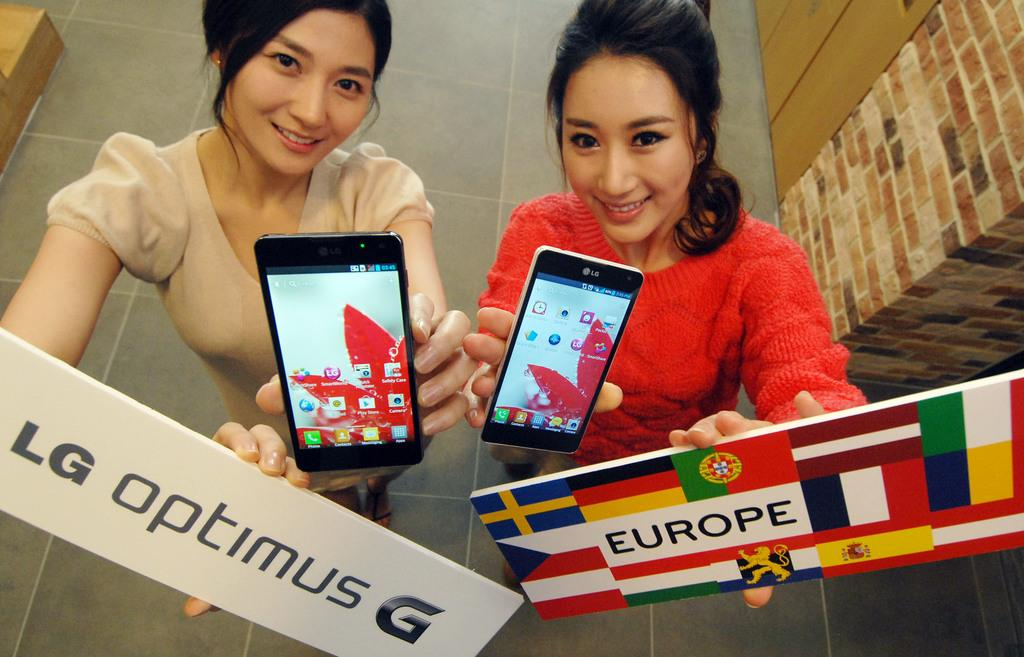<image>
Render a clear and concise summary of the photo. Two women holding LG optimus G phone and europe sign 